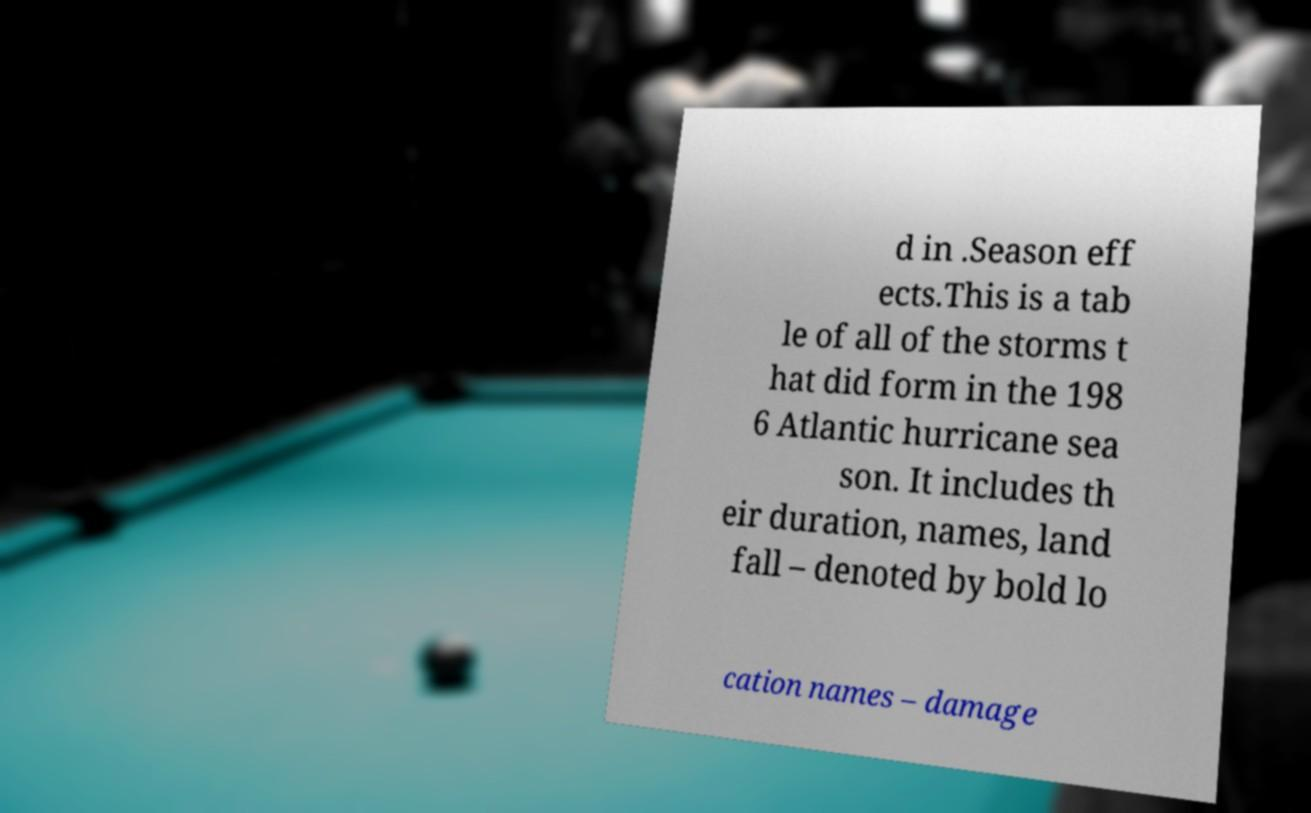I need the written content from this picture converted into text. Can you do that? d in .Season eff ects.This is a tab le of all of the storms t hat did form in the 198 6 Atlantic hurricane sea son. It includes th eir duration, names, land fall – denoted by bold lo cation names – damage 